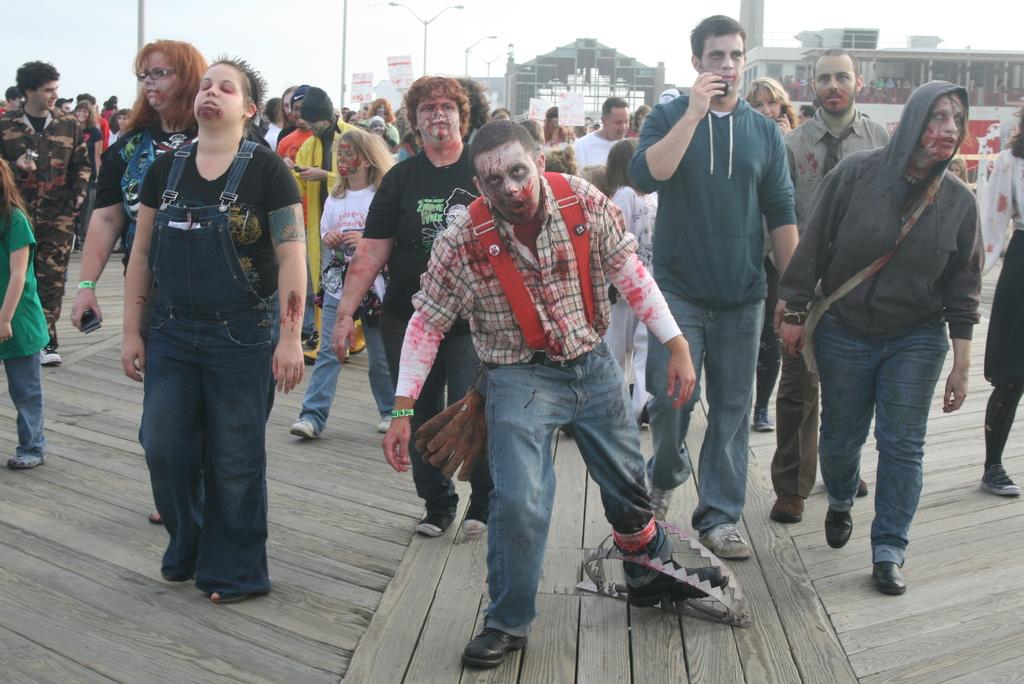What is the group of people in the image doing? The group is doing a zombie walk and giving a pose into the camera. How many people are in the group? The number of people in the group is not specified, but it includes both boys and girls. What can be seen in the background of the image? There is a building and a big arch in the background of the image. What type of bee can be seen buzzing around the group in the image? There is no bee present in the image; the group is focused on their zombie walk and posing for the camera. How many knees are visible in the image? The number of knees visible in the image is not specified, as the focus is on the group's activity and not on individual body parts. 